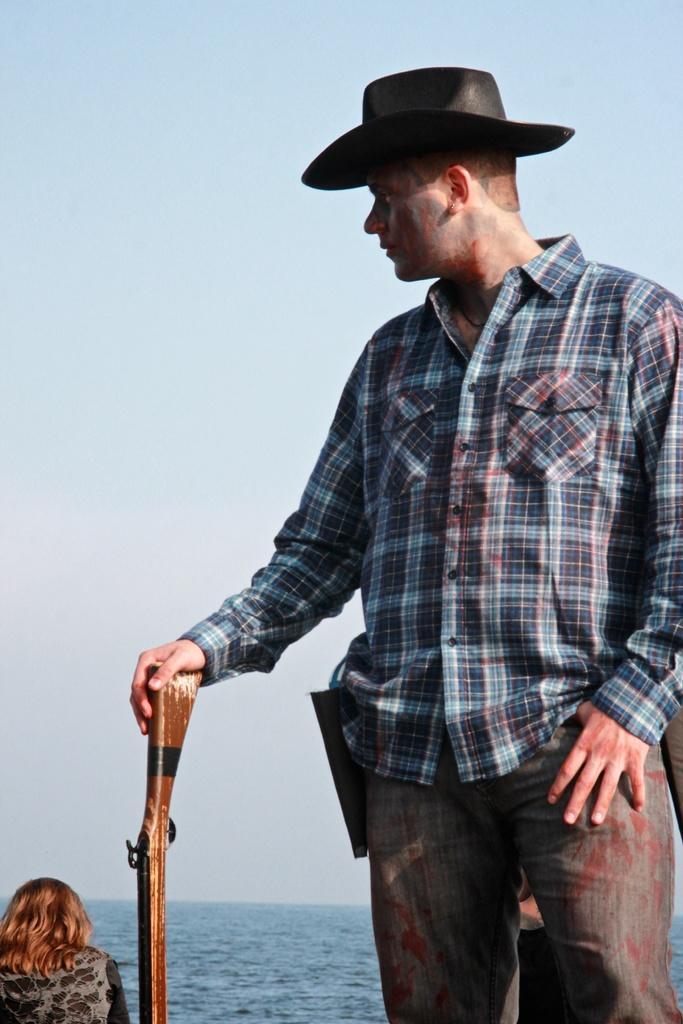Can you describe this image briefly? In this picture we can see a man, he wore a cap, and he is holding a gun, at the left bottom of the image we can see a woman, in the background we can see water. 